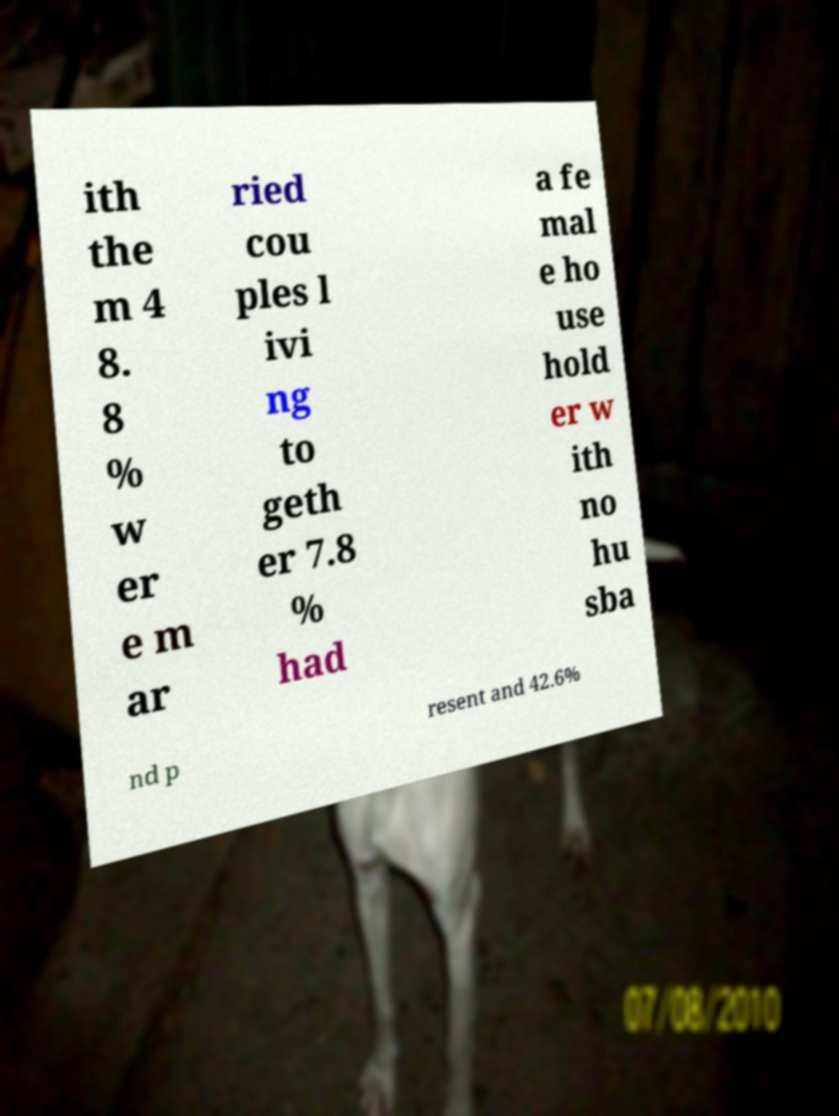Can you accurately transcribe the text from the provided image for me? ith the m 4 8. 8 % w er e m ar ried cou ples l ivi ng to geth er 7.8 % had a fe mal e ho use hold er w ith no hu sba nd p resent and 42.6% 